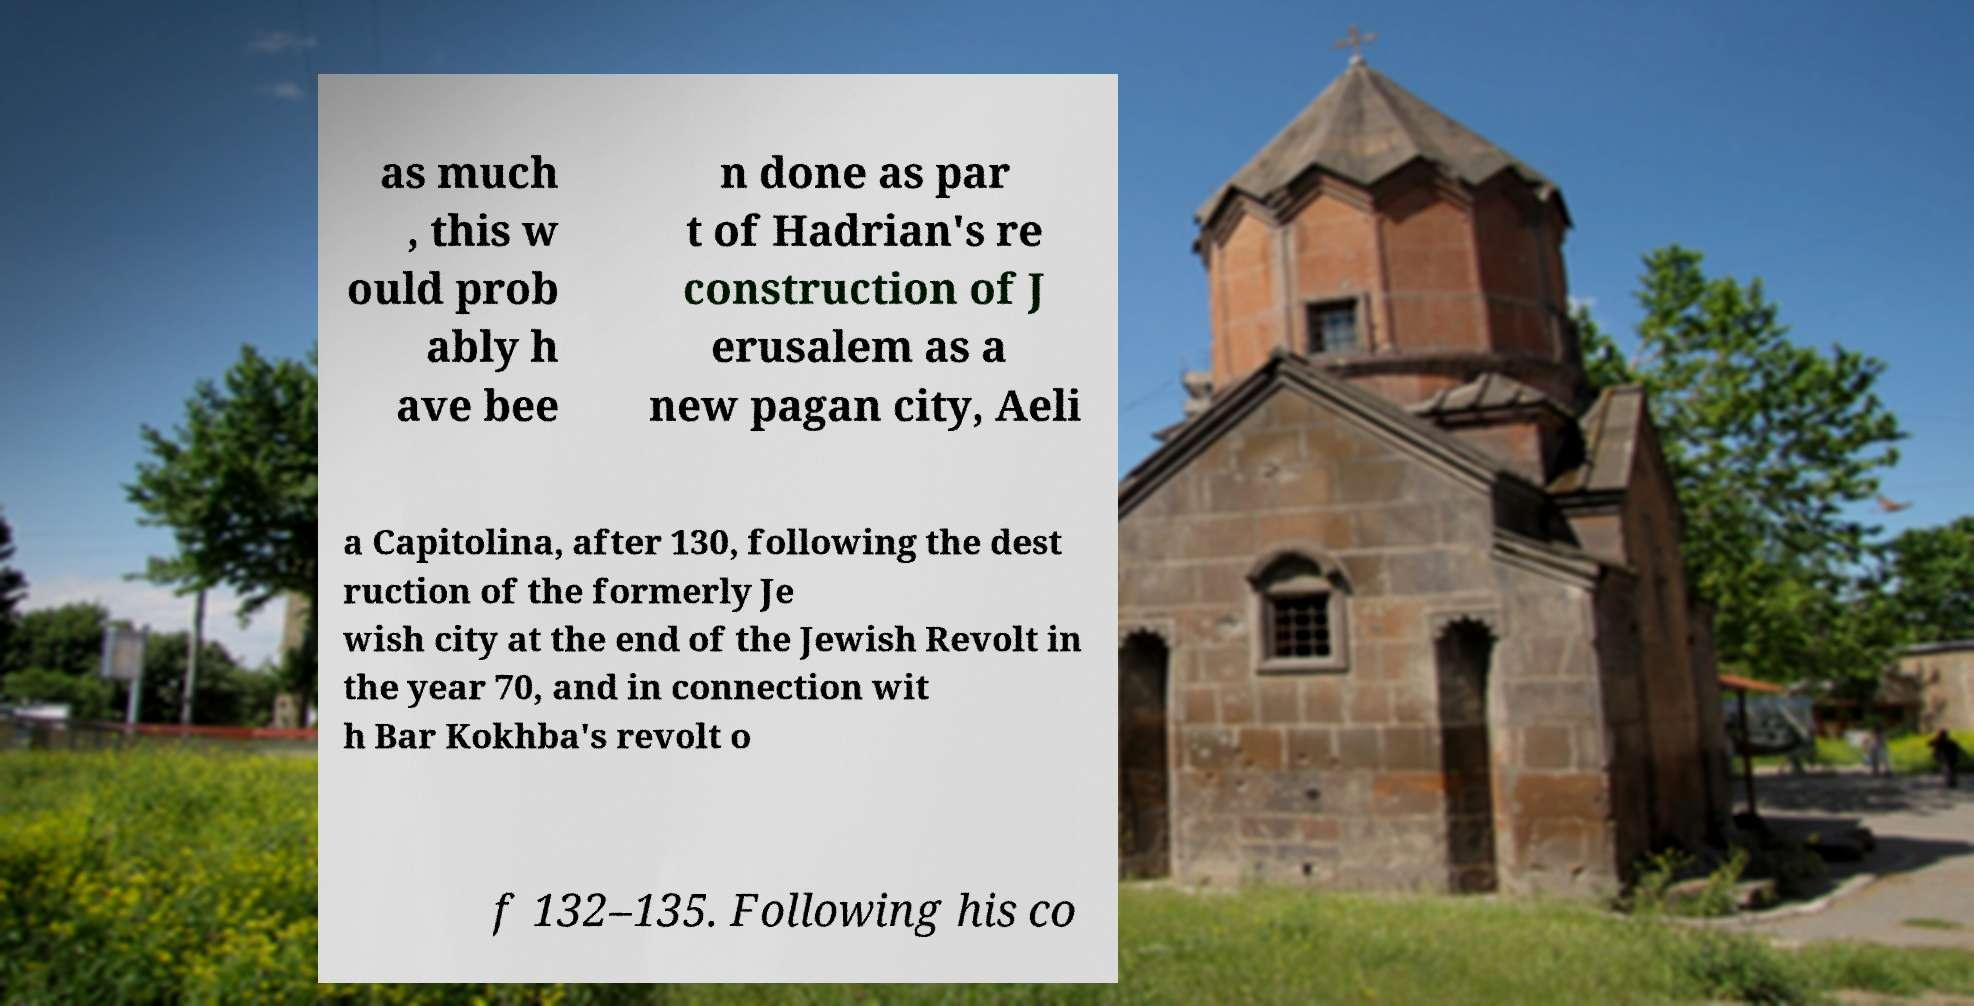Please identify and transcribe the text found in this image. as much , this w ould prob ably h ave bee n done as par t of Hadrian's re construction of J erusalem as a new pagan city, Aeli a Capitolina, after 130, following the dest ruction of the formerly Je wish city at the end of the Jewish Revolt in the year 70, and in connection wit h Bar Kokhba's revolt o f 132–135. Following his co 